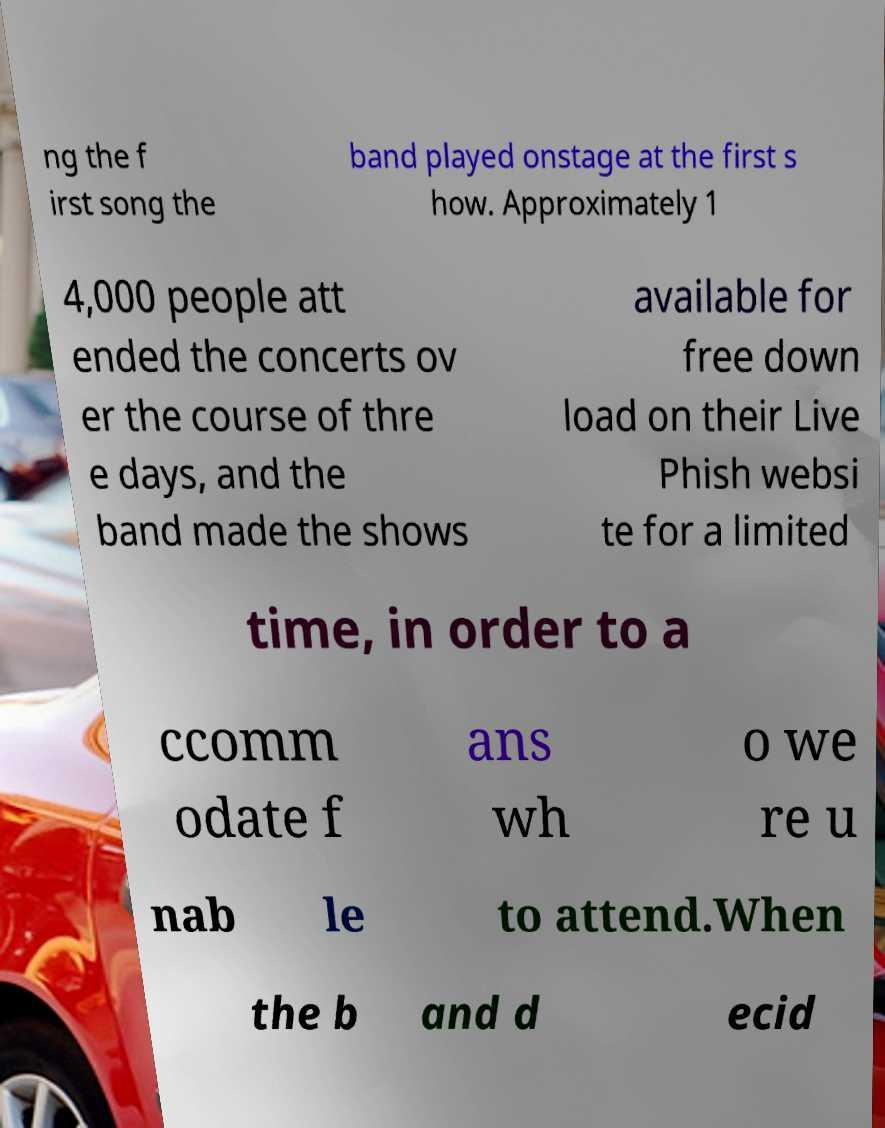Could you assist in decoding the text presented in this image and type it out clearly? ng the f irst song the band played onstage at the first s how. Approximately 1 4,000 people att ended the concerts ov er the course of thre e days, and the band made the shows available for free down load on their Live Phish websi te for a limited time, in order to a ccomm odate f ans wh o we re u nab le to attend.When the b and d ecid 